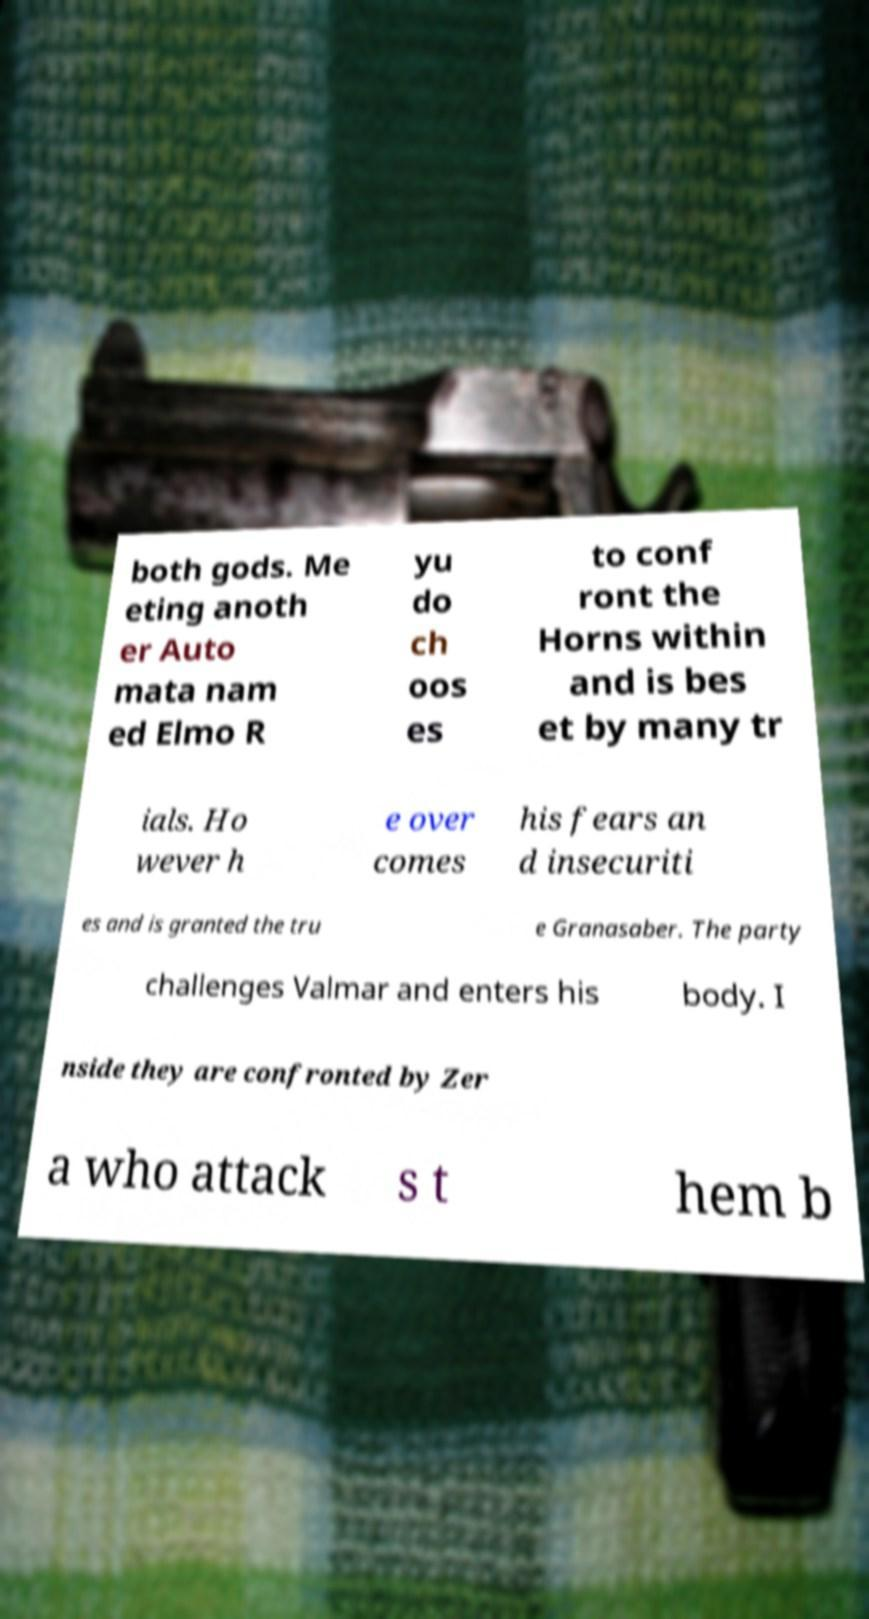Can you read and provide the text displayed in the image?This photo seems to have some interesting text. Can you extract and type it out for me? both gods. Me eting anoth er Auto mata nam ed Elmo R yu do ch oos es to conf ront the Horns within and is bes et by many tr ials. Ho wever h e over comes his fears an d insecuriti es and is granted the tru e Granasaber. The party challenges Valmar and enters his body. I nside they are confronted by Zer a who attack s t hem b 